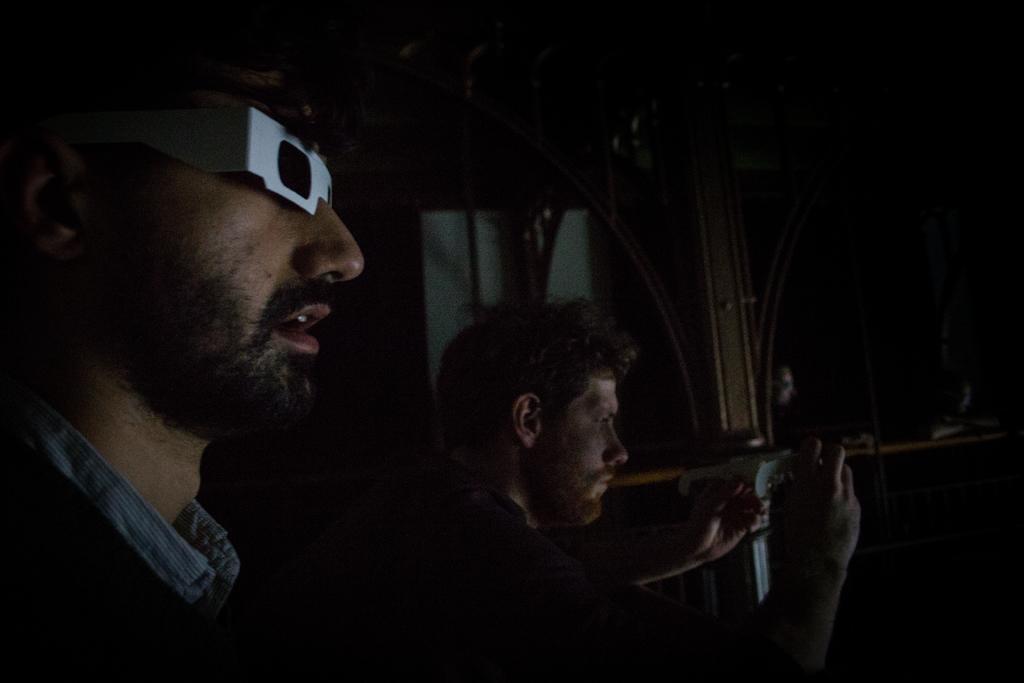In one or two sentences, can you explain what this image depicts? In this image, we can see people and one of them is wearing glasses and the other is holding an object. In the background, we can see some rods and some other objects. 